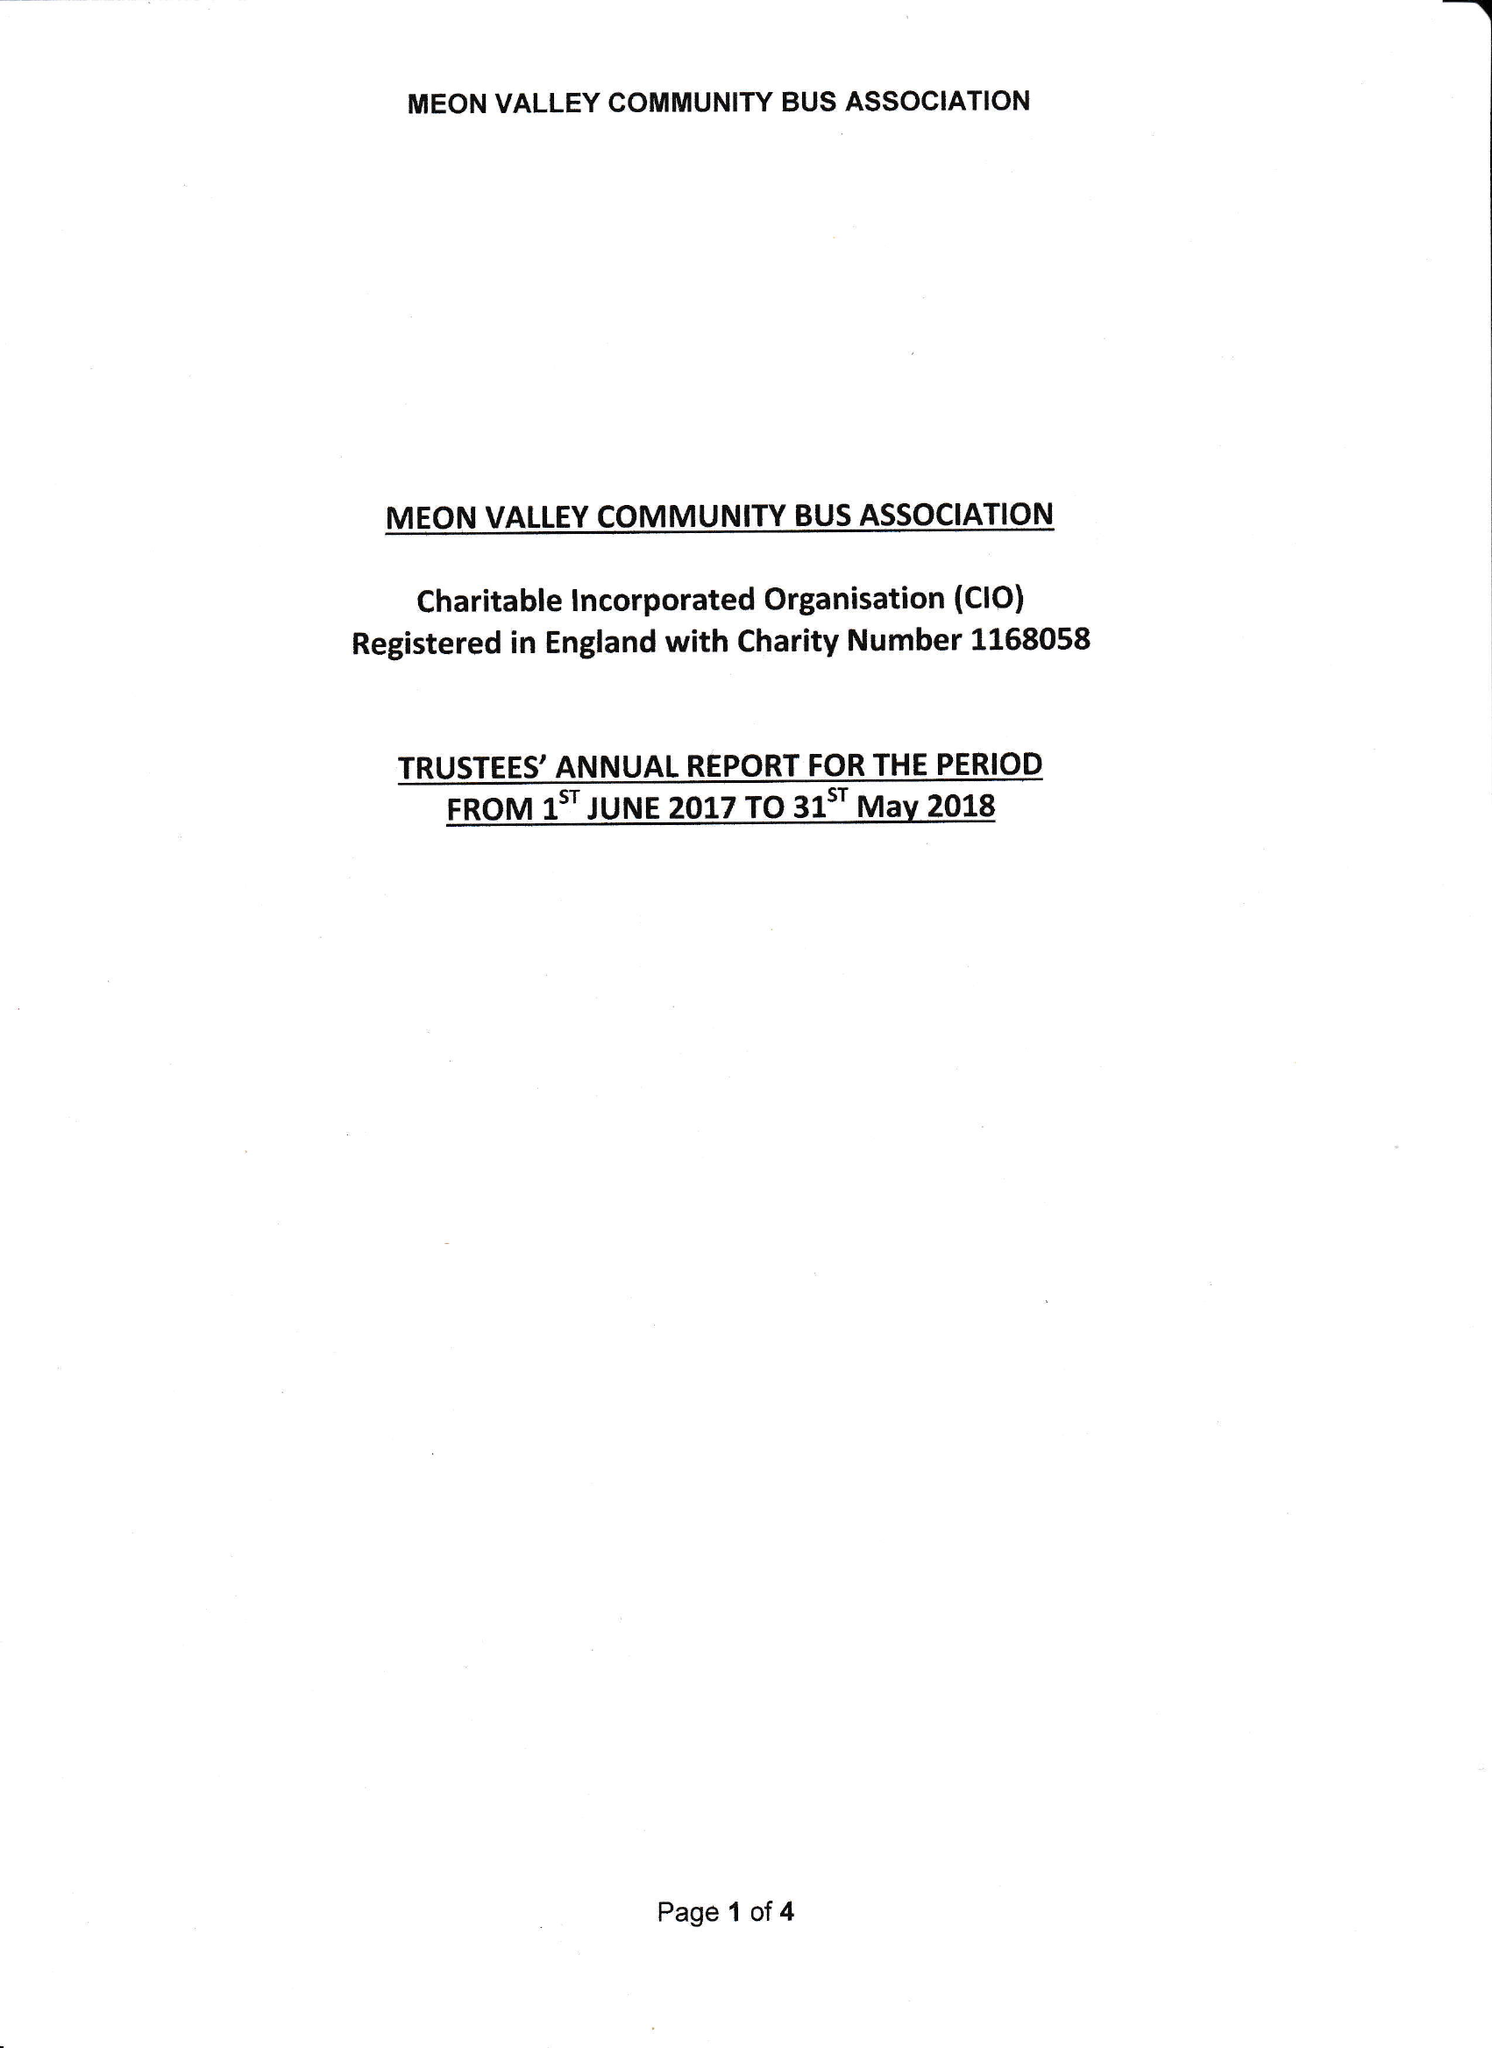What is the value for the charity_number?
Answer the question using a single word or phrase. 1168058 